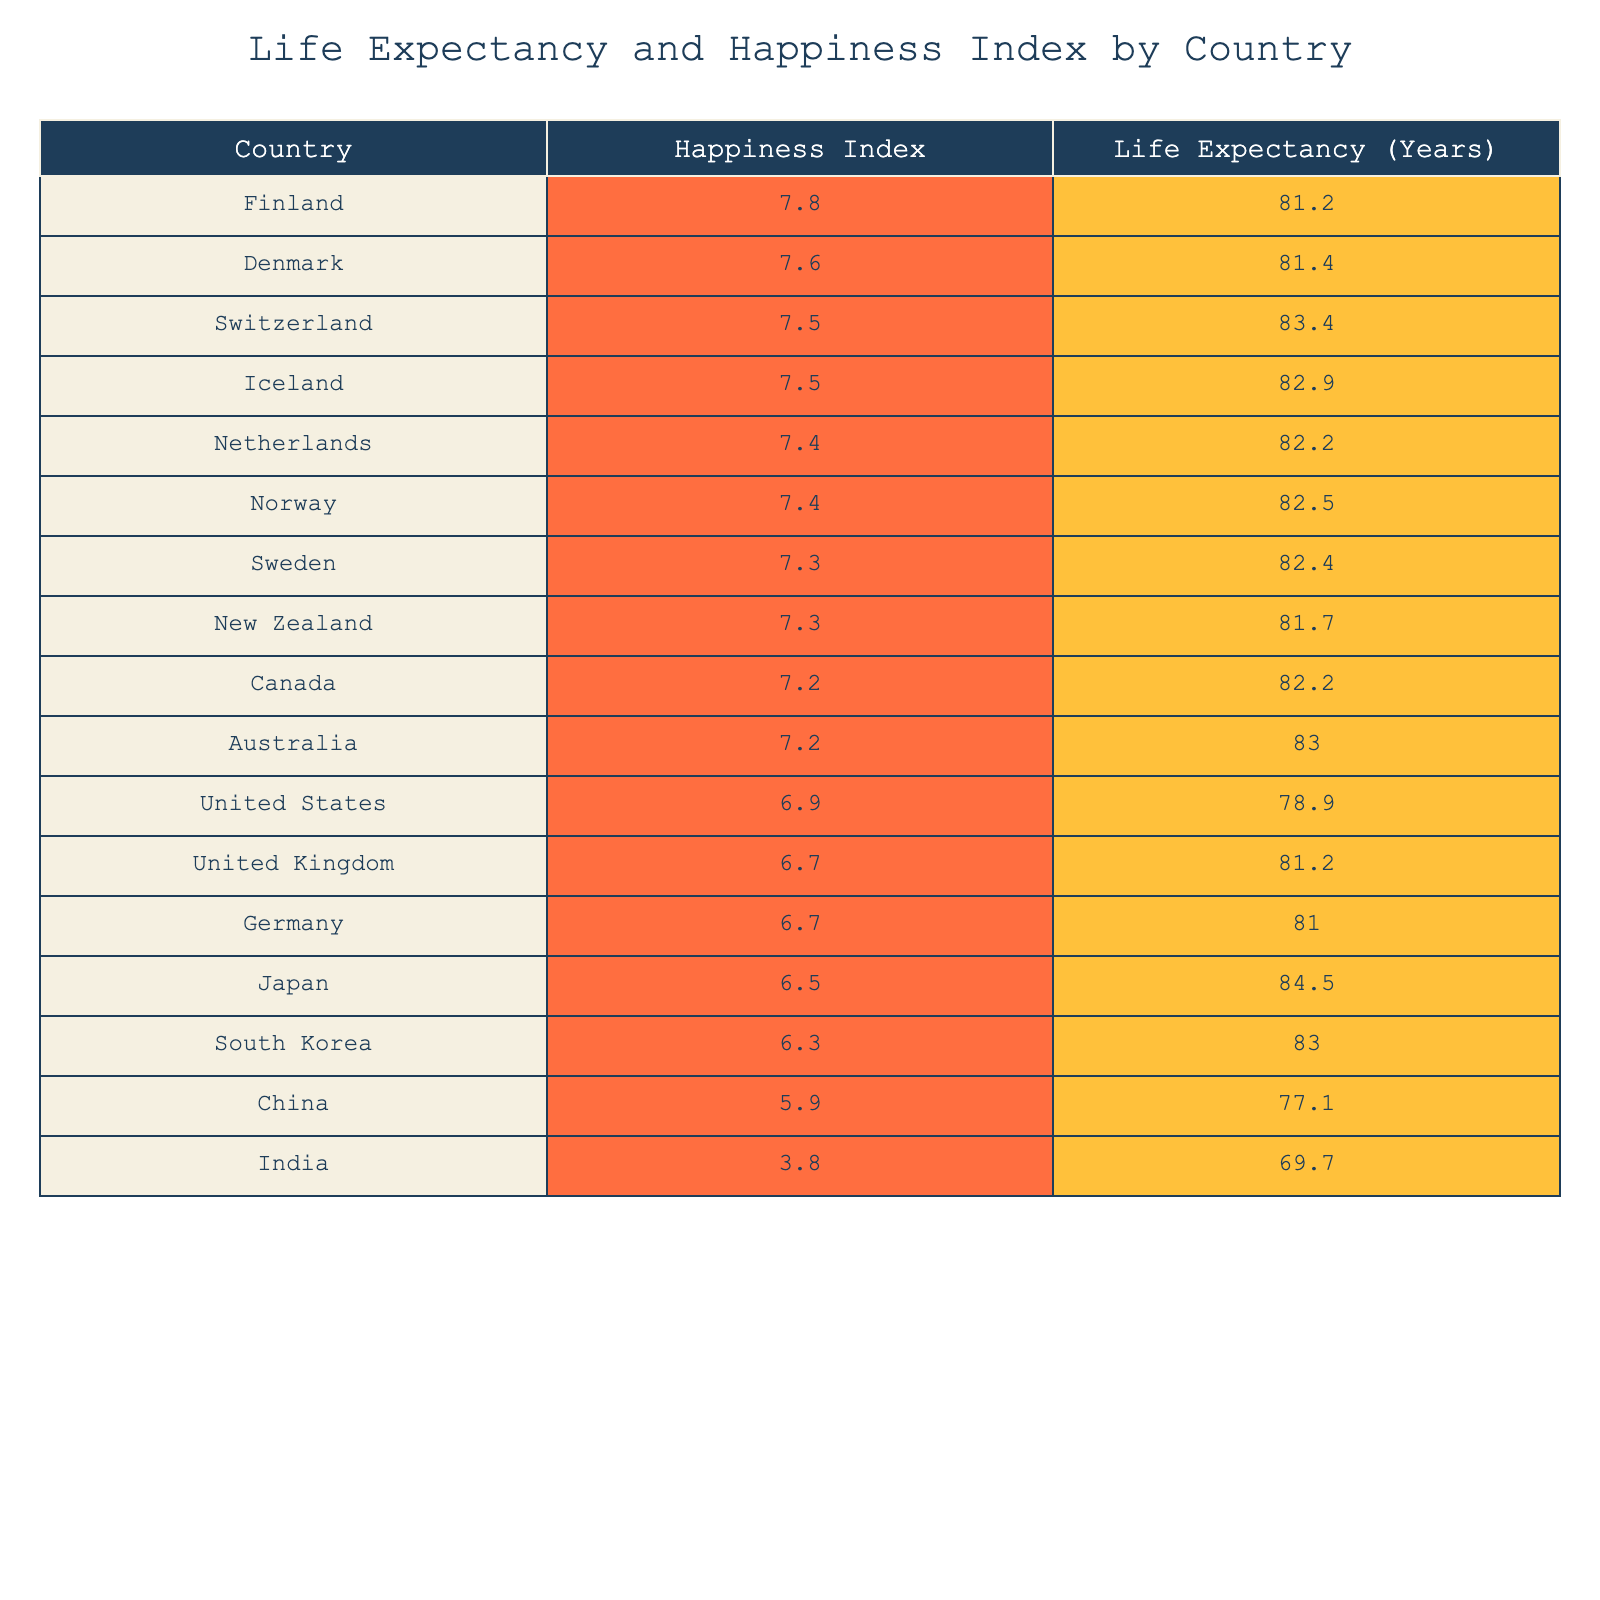What is the life expectancy of Japan? Japan has a life expectancy of 84.5 years according to the table. This value can be directly located in the "Life Expectancy (Years)" column corresponding to Japan.
Answer: 84.5 years Which country has the highest Happiness Index? Finland has the highest Happiness Index at 7.8. It can be found in the "Happiness Index" column, where no other country has a value greater than 7.8.
Answer: Finland What is the average life expectancy of the countries listed? To find the average life expectancy, we first sum the life expectancy values: (81.2 + 81.4 + 83.4 + 82.9 + 82.2 + 82.5 + 82.4 + 81.7 + 82.2 + 83.0 + 78.9 + 81.2 + 81.0 + 84.5 + 83.0 + 77.1 + 69.7) = 1293.5. Since there are 17 countries listed, we divide 1293.5 by 17, resulting in approximately 76.1 years.
Answer: 76.1 years Do countries with a Happiness Index above 7.0 generally have a higher life expectancy than those below 7.0? We can compare the life expectancy of countries with Happiness Indices above and below 7.0. The average life expectancy for countries above 7.0 is 81.76 years, while for countries below 7.0, it is 77.6 years. Therefore, it is true that those with a Happiness Index above 7.0 have higher life expectancy.
Answer: Yes What is the difference in Happiness Index between the highest (Finland) and the lowest (India)? The Happiness Index of Finland is 7.8 and that of India is 3.8. The difference is calculated as 7.8 - 3.8 = 4.0. Thus, we find that there is a significant difference in happiness levels.
Answer: 4.0 